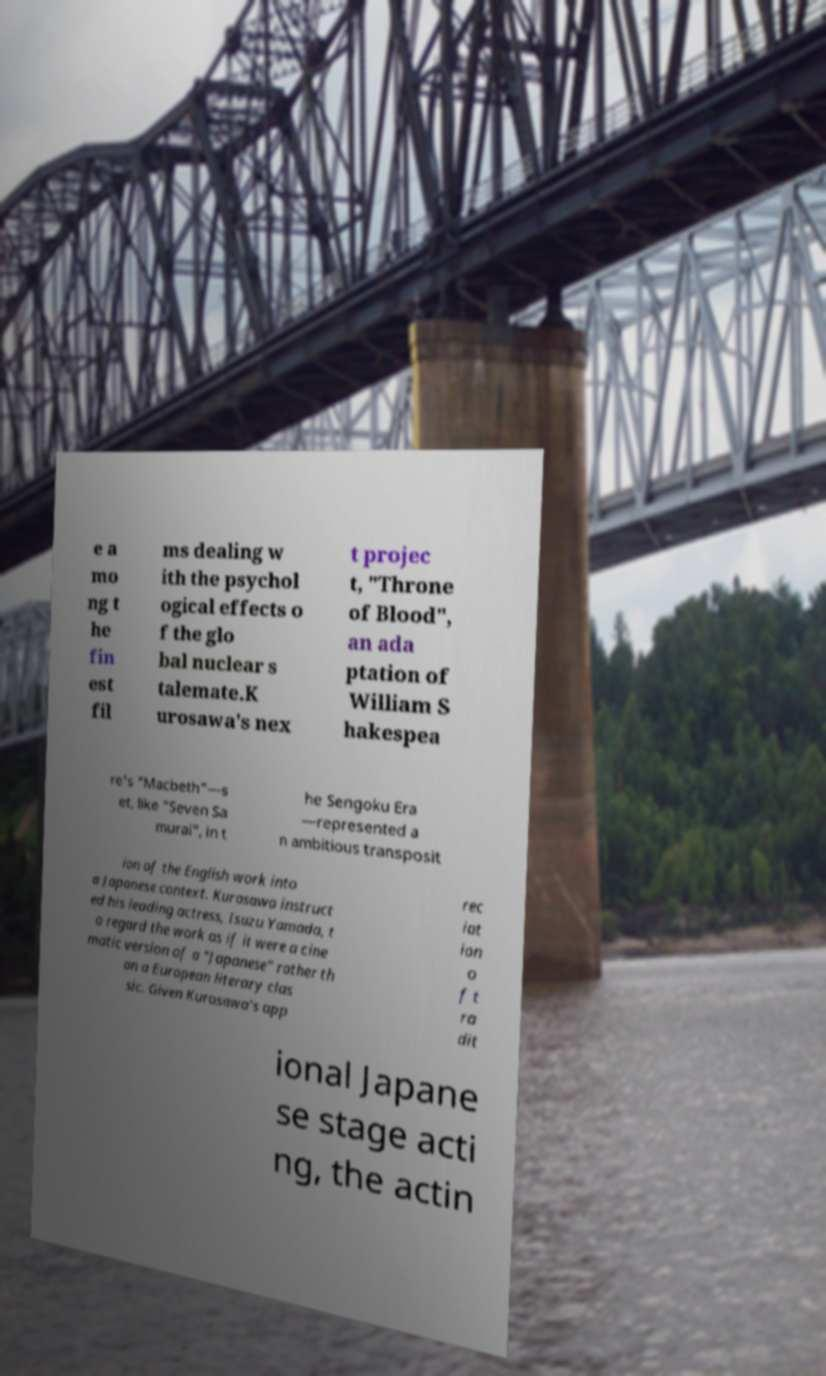Could you extract and type out the text from this image? e a mo ng t he fin est fil ms dealing w ith the psychol ogical effects o f the glo bal nuclear s talemate.K urosawa's nex t projec t, "Throne of Blood", an ada ptation of William S hakespea re's "Macbeth"—s et, like "Seven Sa murai", in t he Sengoku Era —represented a n ambitious transposit ion of the English work into a Japanese context. Kurosawa instruct ed his leading actress, Isuzu Yamada, t o regard the work as if it were a cine matic version of a "Japanese" rather th an a European literary clas sic. Given Kurosawa's app rec iat ion o f t ra dit ional Japane se stage acti ng, the actin 